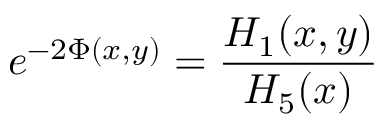Convert formula to latex. <formula><loc_0><loc_0><loc_500><loc_500>e ^ { - 2 \Phi ( x , y ) } = { \frac { H _ { 1 } ( x , y ) } { H _ { 5 } ( x ) } }</formula> 